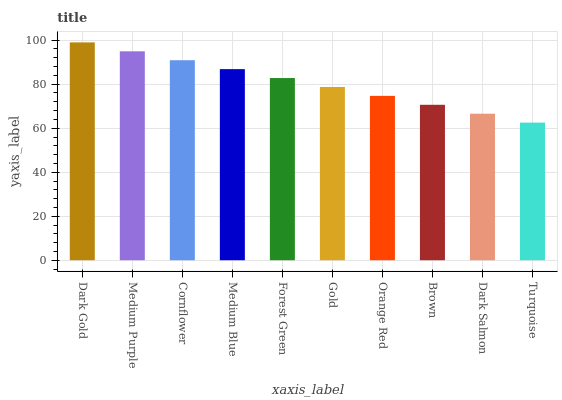Is Turquoise the minimum?
Answer yes or no. Yes. Is Dark Gold the maximum?
Answer yes or no. Yes. Is Medium Purple the minimum?
Answer yes or no. No. Is Medium Purple the maximum?
Answer yes or no. No. Is Dark Gold greater than Medium Purple?
Answer yes or no. Yes. Is Medium Purple less than Dark Gold?
Answer yes or no. Yes. Is Medium Purple greater than Dark Gold?
Answer yes or no. No. Is Dark Gold less than Medium Purple?
Answer yes or no. No. Is Forest Green the high median?
Answer yes or no. Yes. Is Gold the low median?
Answer yes or no. Yes. Is Medium Blue the high median?
Answer yes or no. No. Is Dark Salmon the low median?
Answer yes or no. No. 